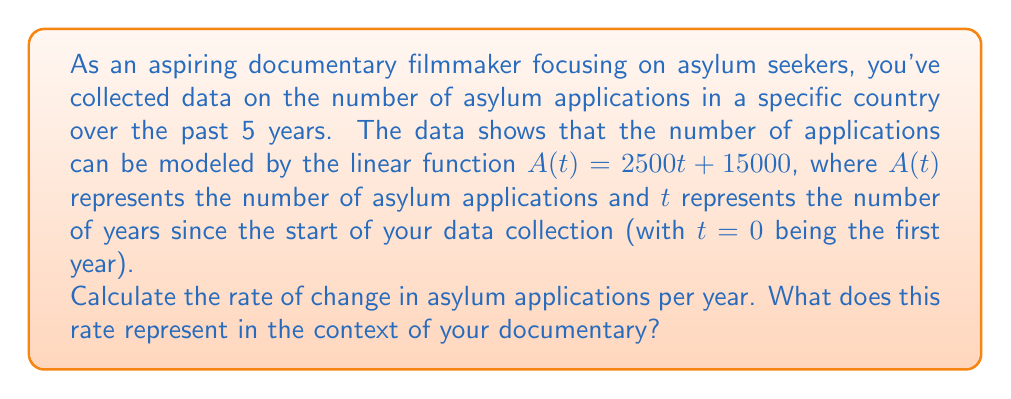What is the answer to this math problem? To solve this problem, we need to understand the concept of rate of change in a linear function.

1) The general form of a linear function is $f(x) = mx + b$, where:
   - $m$ is the slope of the line (rate of change)
   - $b$ is the y-intercept

2) In our case, we have $A(t) = 2500t + 15000$, which is in the form of a linear function where:
   - $A(t)$ is equivalent to $f(x)$
   - $t$ is equivalent to $x$
   - $2500$ is equivalent to $m$ (the slope)
   - $15000$ is equivalent to $b$ (the y-intercept)

3) The rate of change in a linear function is represented by the slope ($m$) of the line.

4) Therefore, the rate of change in asylum applications per year is 2500.

5) In the context of the documentary, this means that each year, the number of asylum applications increases by 2500.

This rate of change provides valuable information for the documentary:
- It shows a steady increase in asylum applications over time.
- It can be used to predict future trends if the pattern continues.
- It highlights the growing pressure on the asylum system in this country.
Answer: The rate of change is 2500 asylum applications per year. 